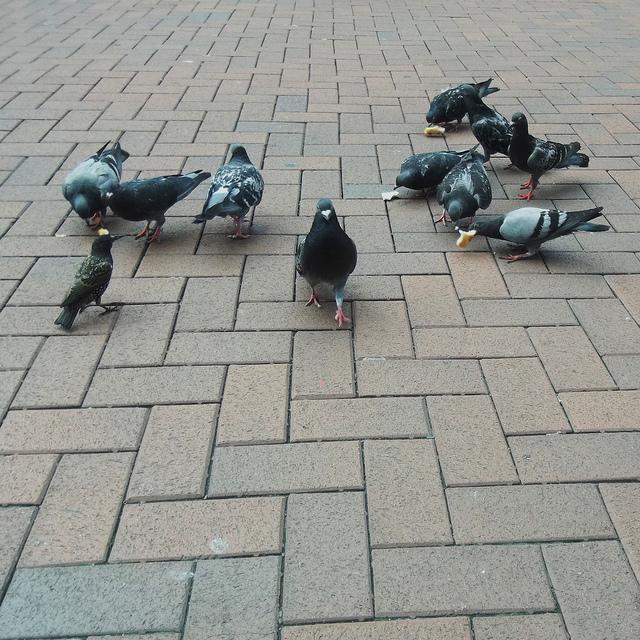How many pigeons are there?
Give a very brief answer. 11. How many birds can be seen?
Give a very brief answer. 7. 